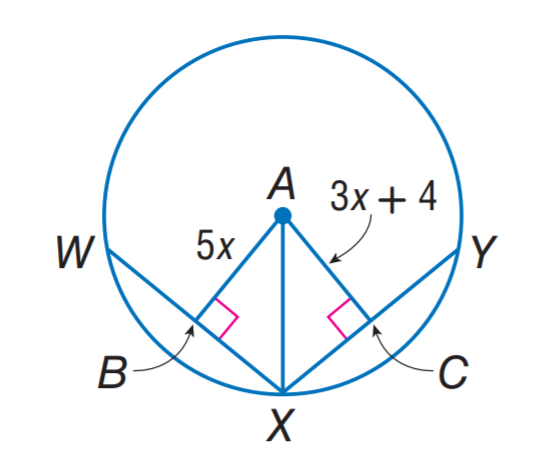Answer the mathemtical geometry problem and directly provide the correct option letter.
Question: In \odot A, W X = X Y = 22. Find A B.
Choices: A: 5 B: 10 C: 11 D: 22 B 